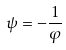<formula> <loc_0><loc_0><loc_500><loc_500>\psi = - \frac { 1 } { \varphi }</formula> 